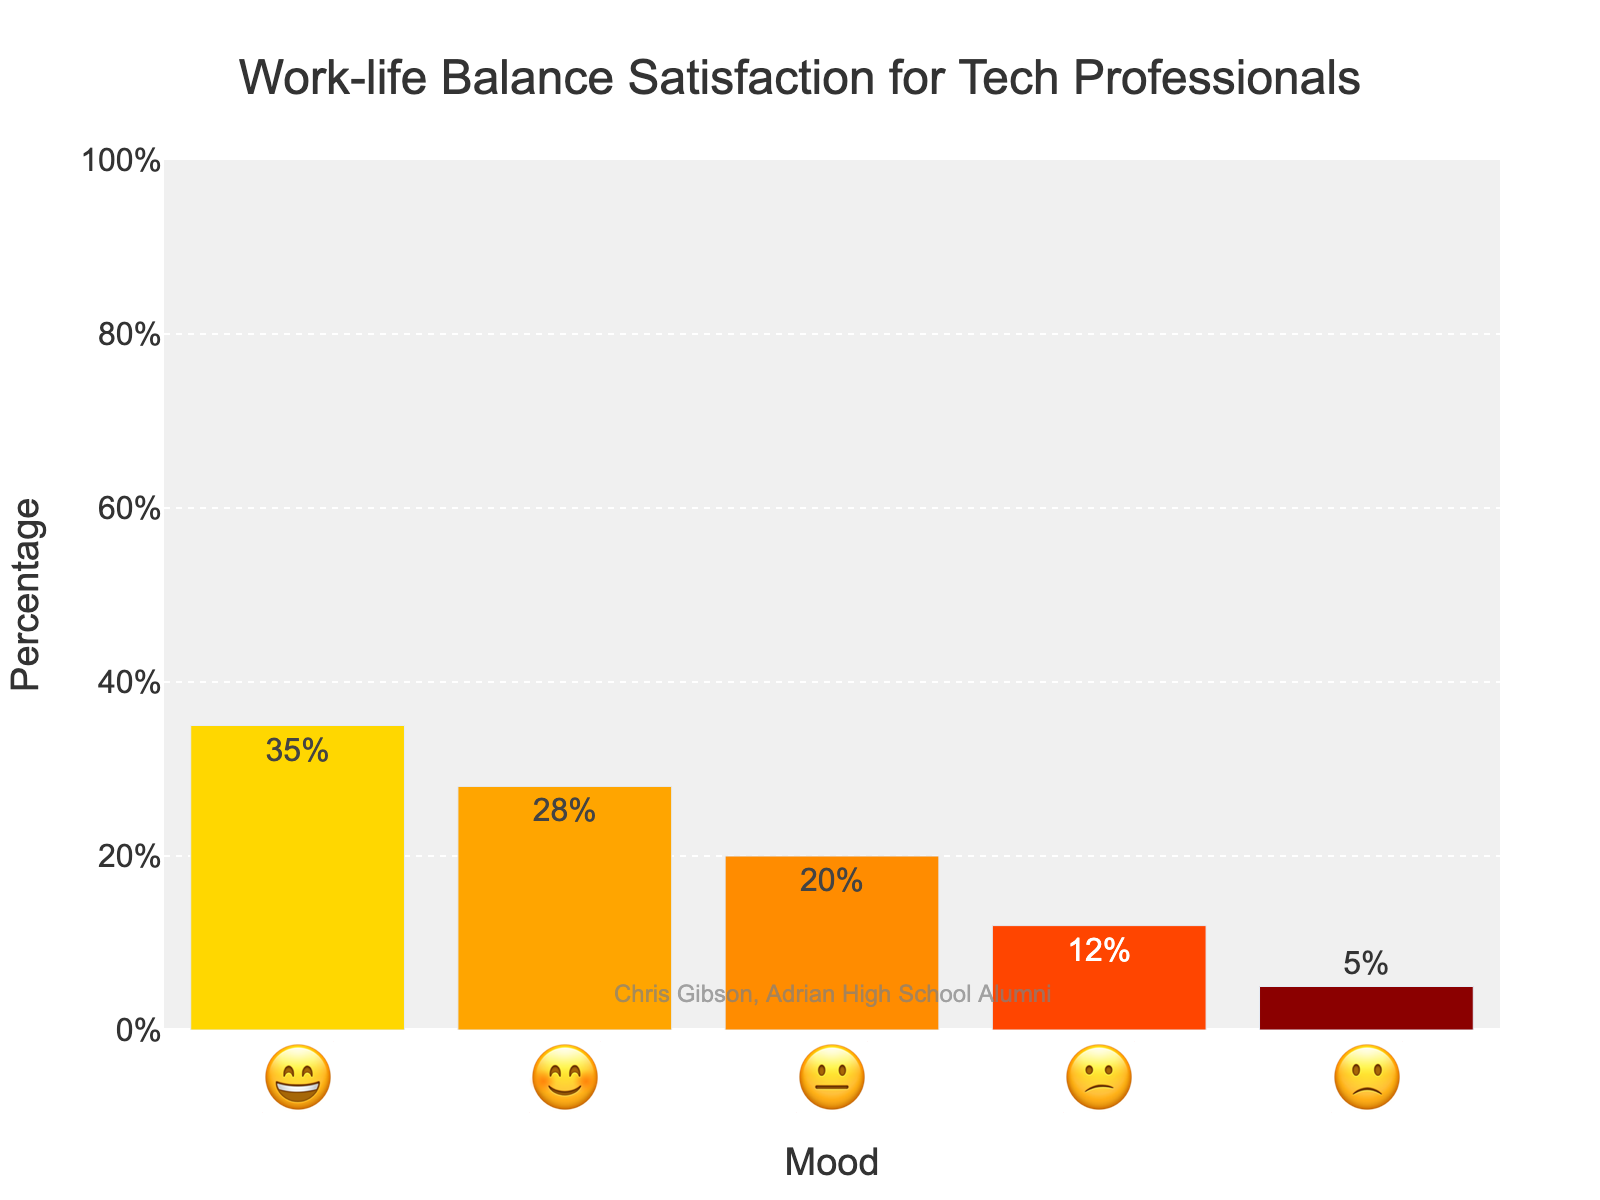What's the title of the chart? The title of the chart is located at the top and provides an overview of what the chart is about.
Answer: Work-life Balance Satisfaction for Tech Professionals Which mood emoji has the highest percentage? To find the emoji with the highest percentage, look for the highest bar and check its corresponding emoji.
Answer: 😄 How many mood emojis are represented in the chart? Count the total number of different emojis along the x-axis to determine how many moods are represented.
Answer: 5 What's the percentage difference between the happiest (😄) and the most dissatisfied (🙁) mood? Subtract the percentage of the least satisfied emoji (🙁, 5%) from the most satisfied emoji (😄, 35%).
Answer: 30% What's the combined percentage of the least satisfied emojis (😕 and 🙁)? Add the percentages of 😕 and 🙁 to find the total combined dissatisfaction.
Answer: 12% + 5% = 17% Which mood emoji has a 20% satisfaction level? Look for the bar with a 20% value on the y-axis and identify its corresponding emoji on the x-axis.
Answer: 😐 Compare the satisfaction levels of 😊 and 😐 emojis. Which is higher and by how much? Subtract the percentage of 😐 (20%) from 😊 (28%) to determine the difference and which one is higher.
Answer: 😊 is higher by 8% What percentage of tech professionals has neutral (😐) or negative (😕, 🙁) work-life balance feelings? Add the percentages for 😐, 😕, and 🙁 to determine the overall percentage of neutral or negative feelings.
Answer: 20% + 12% + 5% = 37% What does the watermark at the bottom of the chart say? The watermark text is located at the bottom of the chart and usually contains information about the creator or source of the chart.
Answer: Chris Gibson, Adrian High School Alumni What's the total percentage of positive satisfaction levels (😄 and 😊)? Add the percentages of 😄 and 😊 to determine the total positive satisfaction levels.
Answer: 35% + 28% = 63% 